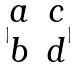Convert formula to latex. <formula><loc_0><loc_0><loc_500><loc_500>| \begin{matrix} a & c \\ b & d \end{matrix} |</formula> 